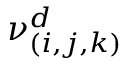<formula> <loc_0><loc_0><loc_500><loc_500>\nu _ { ( i , j , k ) } ^ { d }</formula> 